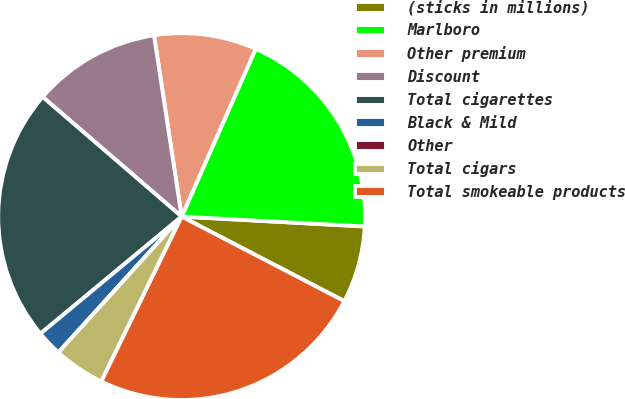Convert chart to OTSL. <chart><loc_0><loc_0><loc_500><loc_500><pie_chart><fcel>(sticks in millions)<fcel>Marlboro<fcel>Other premium<fcel>Discount<fcel>Total cigarettes<fcel>Black & Mild<fcel>Other<fcel>Total cigars<fcel>Total smokeable products<nl><fcel>6.77%<fcel>19.24%<fcel>9.02%<fcel>11.28%<fcel>22.33%<fcel>2.26%<fcel>0.0%<fcel>4.51%<fcel>24.58%<nl></chart> 